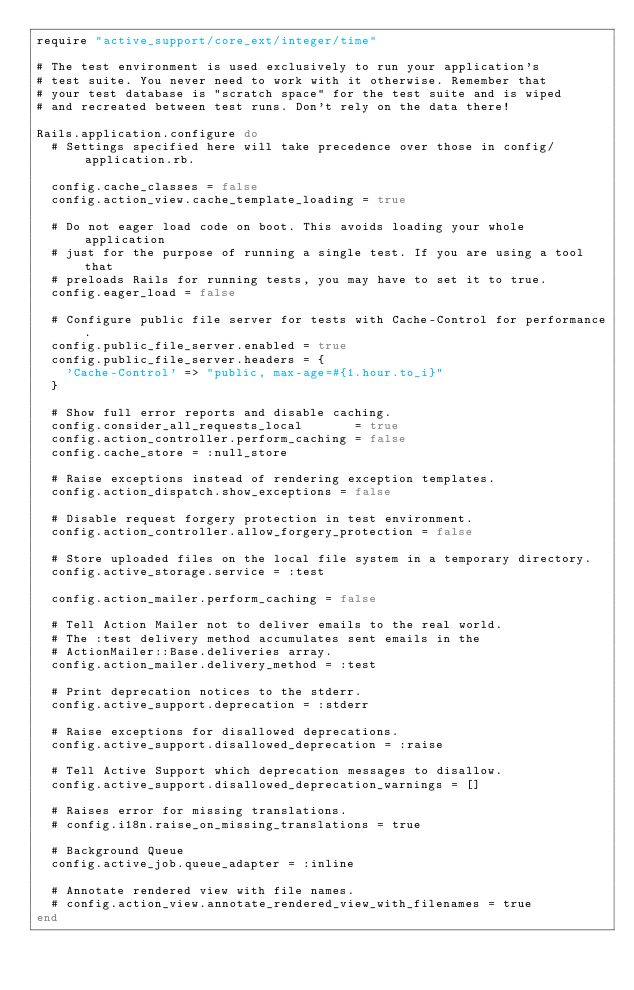<code> <loc_0><loc_0><loc_500><loc_500><_Ruby_>require "active_support/core_ext/integer/time"

# The test environment is used exclusively to run your application's
# test suite. You never need to work with it otherwise. Remember that
# your test database is "scratch space" for the test suite and is wiped
# and recreated between test runs. Don't rely on the data there!

Rails.application.configure do
  # Settings specified here will take precedence over those in config/application.rb.

  config.cache_classes = false
  config.action_view.cache_template_loading = true

  # Do not eager load code on boot. This avoids loading your whole application
  # just for the purpose of running a single test. If you are using a tool that
  # preloads Rails for running tests, you may have to set it to true.
  config.eager_load = false

  # Configure public file server for tests with Cache-Control for performance.
  config.public_file_server.enabled = true
  config.public_file_server.headers = {
    'Cache-Control' => "public, max-age=#{1.hour.to_i}"
  }

  # Show full error reports and disable caching.
  config.consider_all_requests_local       = true
  config.action_controller.perform_caching = false
  config.cache_store = :null_store

  # Raise exceptions instead of rendering exception templates.
  config.action_dispatch.show_exceptions = false

  # Disable request forgery protection in test environment.
  config.action_controller.allow_forgery_protection = false

  # Store uploaded files on the local file system in a temporary directory.
  config.active_storage.service = :test

  config.action_mailer.perform_caching = false

  # Tell Action Mailer not to deliver emails to the real world.
  # The :test delivery method accumulates sent emails in the
  # ActionMailer::Base.deliveries array.
  config.action_mailer.delivery_method = :test

  # Print deprecation notices to the stderr.
  config.active_support.deprecation = :stderr

  # Raise exceptions for disallowed deprecations.
  config.active_support.disallowed_deprecation = :raise

  # Tell Active Support which deprecation messages to disallow.
  config.active_support.disallowed_deprecation_warnings = []

  # Raises error for missing translations.
  # config.i18n.raise_on_missing_translations = true

  # Background Queue
  config.active_job.queue_adapter = :inline

  # Annotate rendered view with file names.
  # config.action_view.annotate_rendered_view_with_filenames = true
end
</code> 